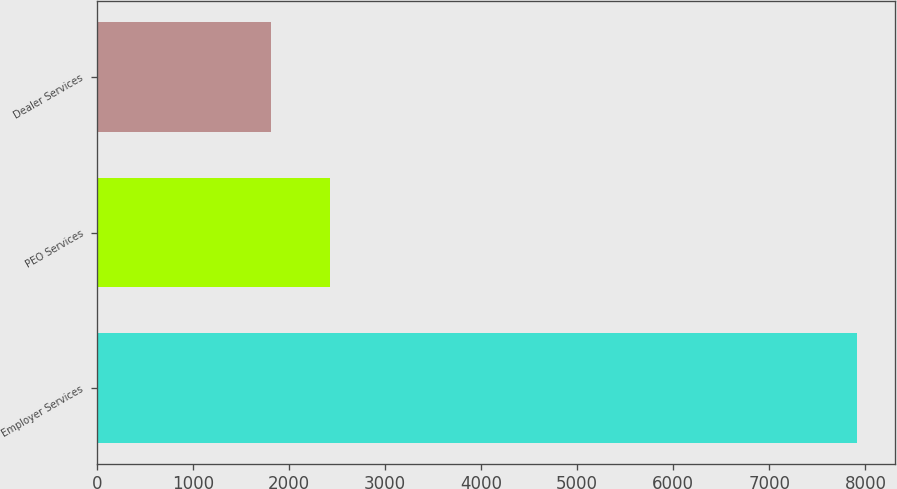Convert chart. <chart><loc_0><loc_0><loc_500><loc_500><bar_chart><fcel>Employer Services<fcel>PEO Services<fcel>Dealer Services<nl><fcel>7914<fcel>2423.73<fcel>1813.7<nl></chart> 